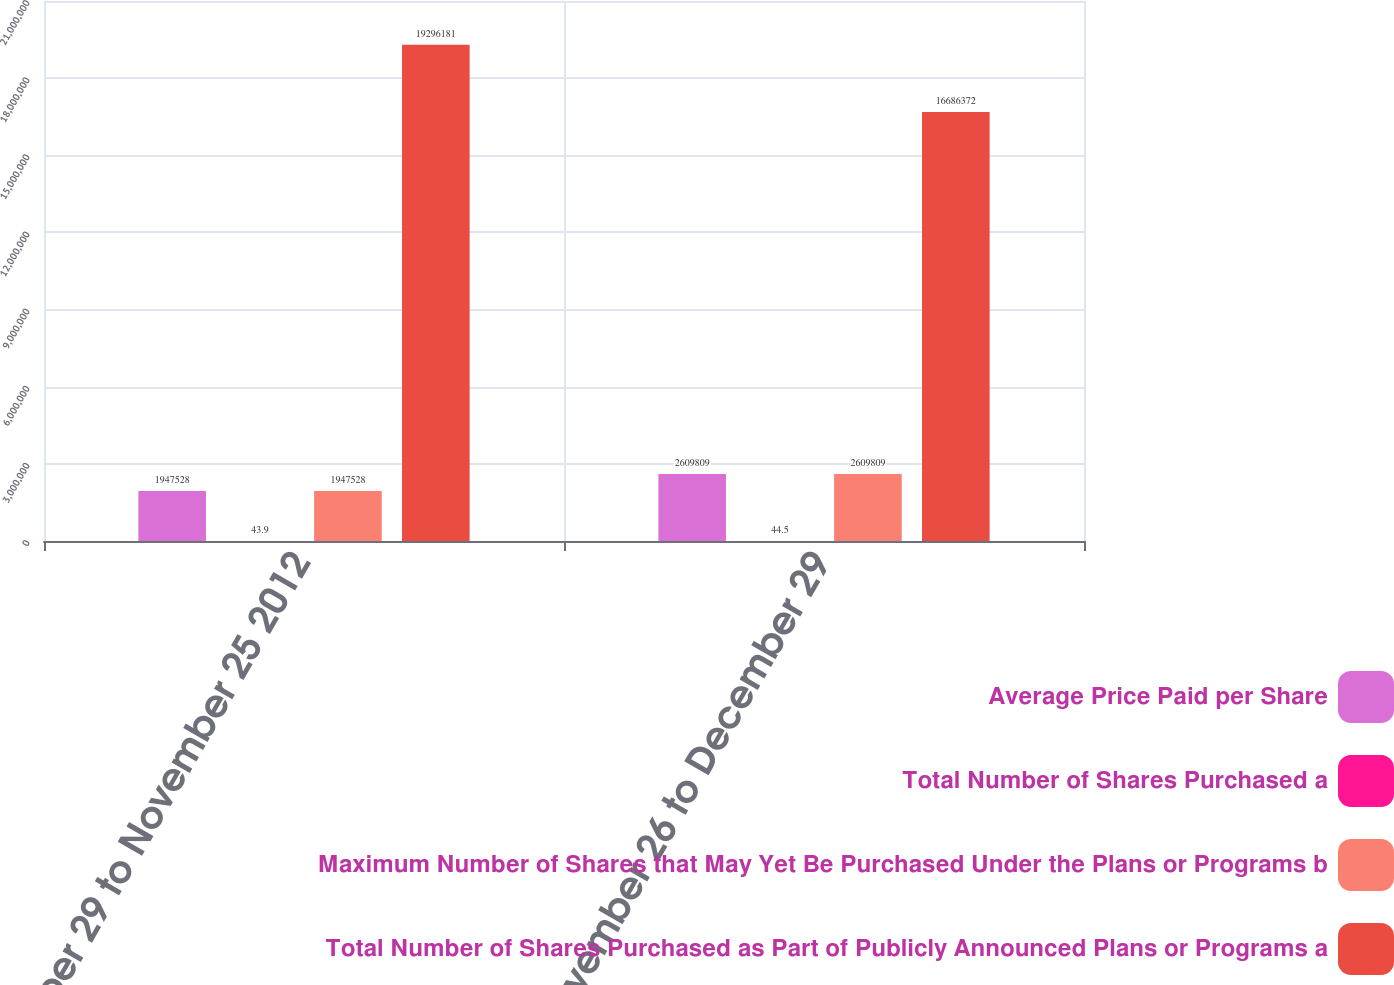Convert chart. <chart><loc_0><loc_0><loc_500><loc_500><stacked_bar_chart><ecel><fcel>October 29 to November 25 2012<fcel>November 26 to December 29<nl><fcel>Average Price Paid per Share<fcel>1.94753e+06<fcel>2.60981e+06<nl><fcel>Total Number of Shares Purchased a<fcel>43.9<fcel>44.5<nl><fcel>Maximum Number of Shares that May Yet Be Purchased Under the Plans or Programs b<fcel>1.94753e+06<fcel>2.60981e+06<nl><fcel>Total Number of Shares Purchased as Part of Publicly Announced Plans or Programs a<fcel>1.92962e+07<fcel>1.66864e+07<nl></chart> 